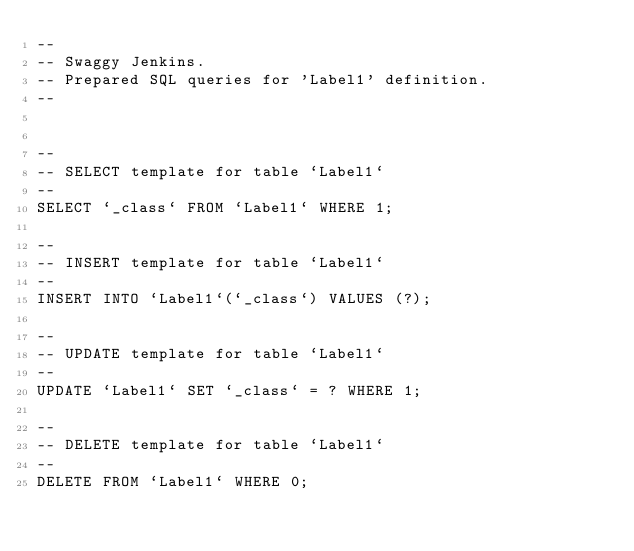Convert code to text. <code><loc_0><loc_0><loc_500><loc_500><_SQL_>--
-- Swaggy Jenkins.
-- Prepared SQL queries for 'Label1' definition.
--


--
-- SELECT template for table `Label1`
--
SELECT `_class` FROM `Label1` WHERE 1;

--
-- INSERT template for table `Label1`
--
INSERT INTO `Label1`(`_class`) VALUES (?);

--
-- UPDATE template for table `Label1`
--
UPDATE `Label1` SET `_class` = ? WHERE 1;

--
-- DELETE template for table `Label1`
--
DELETE FROM `Label1` WHERE 0;

</code> 